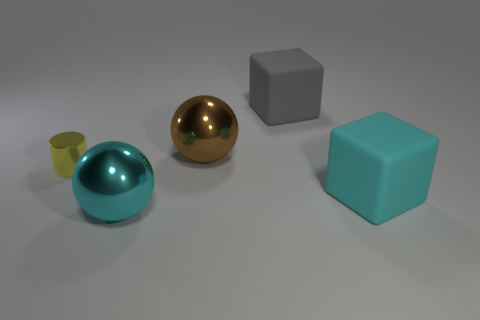Are there fewer yellow shiny things than small blue matte cubes?
Provide a succinct answer. No. Is the shape of the thing on the right side of the gray thing the same as the matte object behind the brown ball?
Offer a terse response. Yes. What number of objects are blue shiny spheres or large matte cubes?
Your answer should be compact. 2. What is the color of the metal object that is the same size as the brown sphere?
Offer a terse response. Cyan. There is a big cube that is left of the large cyan rubber block; what number of small yellow cylinders are behind it?
Provide a short and direct response. 0. How many big objects are behind the yellow cylinder and on the right side of the gray object?
Ensure brevity in your answer.  0. How many things are large metal spheres behind the big cyan rubber cube or blocks behind the cyan rubber object?
Your answer should be very brief. 2. How many other things are the same size as the yellow cylinder?
Offer a very short reply. 0. There is a object that is behind the ball that is behind the tiny yellow metallic thing; what is its shape?
Offer a terse response. Cube. Does the large metal thing that is in front of the tiny yellow metallic thing have the same color as the big cube in front of the small yellow metal object?
Give a very brief answer. Yes. 